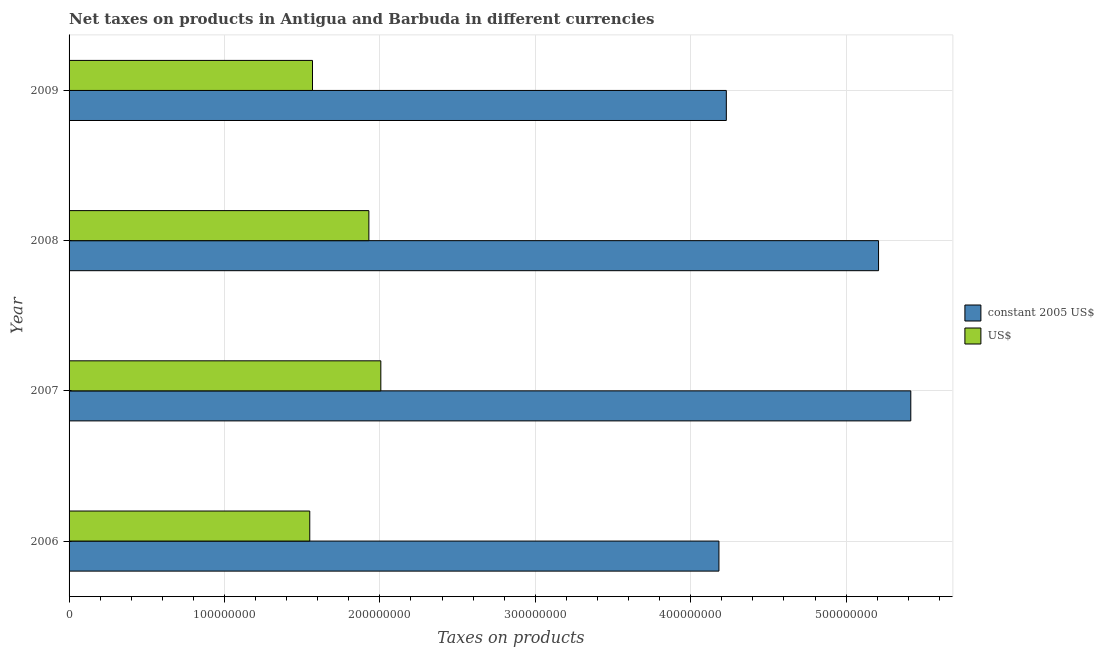How many bars are there on the 1st tick from the top?
Keep it short and to the point. 2. How many bars are there on the 3rd tick from the bottom?
Give a very brief answer. 2. What is the net taxes in constant 2005 us$ in 2008?
Offer a terse response. 5.21e+08. Across all years, what is the maximum net taxes in us$?
Provide a succinct answer. 2.01e+08. Across all years, what is the minimum net taxes in us$?
Offer a terse response. 1.55e+08. In which year was the net taxes in constant 2005 us$ minimum?
Offer a very short reply. 2006. What is the total net taxes in constant 2005 us$ in the graph?
Provide a short and direct response. 1.90e+09. What is the difference between the net taxes in constant 2005 us$ in 2007 and that in 2008?
Ensure brevity in your answer.  2.07e+07. What is the difference between the net taxes in us$ in 2006 and the net taxes in constant 2005 us$ in 2009?
Your response must be concise. -2.68e+08. What is the average net taxes in constant 2005 us$ per year?
Make the answer very short. 4.76e+08. In the year 2008, what is the difference between the net taxes in us$ and net taxes in constant 2005 us$?
Your answer should be very brief. -3.28e+08. In how many years, is the net taxes in constant 2005 us$ greater than 40000000 units?
Provide a succinct answer. 4. What is the ratio of the net taxes in us$ in 2008 to that in 2009?
Offer a terse response. 1.23. Is the net taxes in constant 2005 us$ in 2006 less than that in 2009?
Keep it short and to the point. Yes. What is the difference between the highest and the second highest net taxes in us$?
Offer a very short reply. 7.68e+06. What is the difference between the highest and the lowest net taxes in constant 2005 us$?
Offer a terse response. 1.23e+08. What does the 2nd bar from the top in 2009 represents?
Your response must be concise. Constant 2005 us$. What does the 2nd bar from the bottom in 2008 represents?
Provide a short and direct response. US$. Are all the bars in the graph horizontal?
Offer a terse response. Yes. Are the values on the major ticks of X-axis written in scientific E-notation?
Make the answer very short. No. Does the graph contain any zero values?
Give a very brief answer. No. How many legend labels are there?
Your answer should be very brief. 2. How are the legend labels stacked?
Provide a succinct answer. Vertical. What is the title of the graph?
Provide a succinct answer. Net taxes on products in Antigua and Barbuda in different currencies. What is the label or title of the X-axis?
Make the answer very short. Taxes on products. What is the label or title of the Y-axis?
Keep it short and to the point. Year. What is the Taxes on products in constant 2005 US$ in 2006?
Ensure brevity in your answer.  4.18e+08. What is the Taxes on products in US$ in 2006?
Give a very brief answer. 1.55e+08. What is the Taxes on products of constant 2005 US$ in 2007?
Your answer should be very brief. 5.42e+08. What is the Taxes on products in US$ in 2007?
Give a very brief answer. 2.01e+08. What is the Taxes on products of constant 2005 US$ in 2008?
Your answer should be compact. 5.21e+08. What is the Taxes on products in US$ in 2008?
Your answer should be very brief. 1.93e+08. What is the Taxes on products of constant 2005 US$ in 2009?
Your response must be concise. 4.23e+08. What is the Taxes on products in US$ in 2009?
Give a very brief answer. 1.57e+08. Across all years, what is the maximum Taxes on products of constant 2005 US$?
Provide a succinct answer. 5.42e+08. Across all years, what is the maximum Taxes on products in US$?
Keep it short and to the point. 2.01e+08. Across all years, what is the minimum Taxes on products of constant 2005 US$?
Your answer should be very brief. 4.18e+08. Across all years, what is the minimum Taxes on products of US$?
Offer a very short reply. 1.55e+08. What is the total Taxes on products in constant 2005 US$ in the graph?
Your answer should be very brief. 1.90e+09. What is the total Taxes on products in US$ in the graph?
Your answer should be compact. 7.05e+08. What is the difference between the Taxes on products in constant 2005 US$ in 2006 and that in 2007?
Your answer should be very brief. -1.23e+08. What is the difference between the Taxes on products of US$ in 2006 and that in 2007?
Provide a succinct answer. -4.57e+07. What is the difference between the Taxes on products of constant 2005 US$ in 2006 and that in 2008?
Offer a very short reply. -1.03e+08. What is the difference between the Taxes on products of US$ in 2006 and that in 2008?
Provide a succinct answer. -3.80e+07. What is the difference between the Taxes on products in constant 2005 US$ in 2006 and that in 2009?
Ensure brevity in your answer.  -4.75e+06. What is the difference between the Taxes on products in US$ in 2006 and that in 2009?
Provide a succinct answer. -1.76e+06. What is the difference between the Taxes on products in constant 2005 US$ in 2007 and that in 2008?
Offer a very short reply. 2.07e+07. What is the difference between the Taxes on products of US$ in 2007 and that in 2008?
Keep it short and to the point. 7.68e+06. What is the difference between the Taxes on products of constant 2005 US$ in 2007 and that in 2009?
Provide a short and direct response. 1.19e+08. What is the difference between the Taxes on products in US$ in 2007 and that in 2009?
Your response must be concise. 4.40e+07. What is the difference between the Taxes on products of constant 2005 US$ in 2008 and that in 2009?
Ensure brevity in your answer.  9.80e+07. What is the difference between the Taxes on products in US$ in 2008 and that in 2009?
Make the answer very short. 3.63e+07. What is the difference between the Taxes on products of constant 2005 US$ in 2006 and the Taxes on products of US$ in 2007?
Offer a very short reply. 2.18e+08. What is the difference between the Taxes on products of constant 2005 US$ in 2006 and the Taxes on products of US$ in 2008?
Provide a short and direct response. 2.25e+08. What is the difference between the Taxes on products of constant 2005 US$ in 2006 and the Taxes on products of US$ in 2009?
Your answer should be compact. 2.62e+08. What is the difference between the Taxes on products in constant 2005 US$ in 2007 and the Taxes on products in US$ in 2008?
Keep it short and to the point. 3.49e+08. What is the difference between the Taxes on products in constant 2005 US$ in 2007 and the Taxes on products in US$ in 2009?
Give a very brief answer. 3.85e+08. What is the difference between the Taxes on products in constant 2005 US$ in 2008 and the Taxes on products in US$ in 2009?
Keep it short and to the point. 3.64e+08. What is the average Taxes on products in constant 2005 US$ per year?
Give a very brief answer. 4.76e+08. What is the average Taxes on products in US$ per year?
Your answer should be very brief. 1.76e+08. In the year 2006, what is the difference between the Taxes on products in constant 2005 US$ and Taxes on products in US$?
Your response must be concise. 2.63e+08. In the year 2007, what is the difference between the Taxes on products in constant 2005 US$ and Taxes on products in US$?
Your answer should be compact. 3.41e+08. In the year 2008, what is the difference between the Taxes on products in constant 2005 US$ and Taxes on products in US$?
Your answer should be very brief. 3.28e+08. In the year 2009, what is the difference between the Taxes on products in constant 2005 US$ and Taxes on products in US$?
Make the answer very short. 2.66e+08. What is the ratio of the Taxes on products in constant 2005 US$ in 2006 to that in 2007?
Make the answer very short. 0.77. What is the ratio of the Taxes on products of US$ in 2006 to that in 2007?
Provide a short and direct response. 0.77. What is the ratio of the Taxes on products in constant 2005 US$ in 2006 to that in 2008?
Give a very brief answer. 0.8. What is the ratio of the Taxes on products in US$ in 2006 to that in 2008?
Make the answer very short. 0.8. What is the ratio of the Taxes on products of US$ in 2006 to that in 2009?
Offer a terse response. 0.99. What is the ratio of the Taxes on products in constant 2005 US$ in 2007 to that in 2008?
Your answer should be very brief. 1.04. What is the ratio of the Taxes on products of US$ in 2007 to that in 2008?
Your answer should be very brief. 1.04. What is the ratio of the Taxes on products in constant 2005 US$ in 2007 to that in 2009?
Ensure brevity in your answer.  1.28. What is the ratio of the Taxes on products of US$ in 2007 to that in 2009?
Keep it short and to the point. 1.28. What is the ratio of the Taxes on products in constant 2005 US$ in 2008 to that in 2009?
Offer a terse response. 1.23. What is the ratio of the Taxes on products of US$ in 2008 to that in 2009?
Keep it short and to the point. 1.23. What is the difference between the highest and the second highest Taxes on products of constant 2005 US$?
Offer a terse response. 2.07e+07. What is the difference between the highest and the second highest Taxes on products in US$?
Ensure brevity in your answer.  7.68e+06. What is the difference between the highest and the lowest Taxes on products in constant 2005 US$?
Offer a very short reply. 1.23e+08. What is the difference between the highest and the lowest Taxes on products in US$?
Your answer should be very brief. 4.57e+07. 